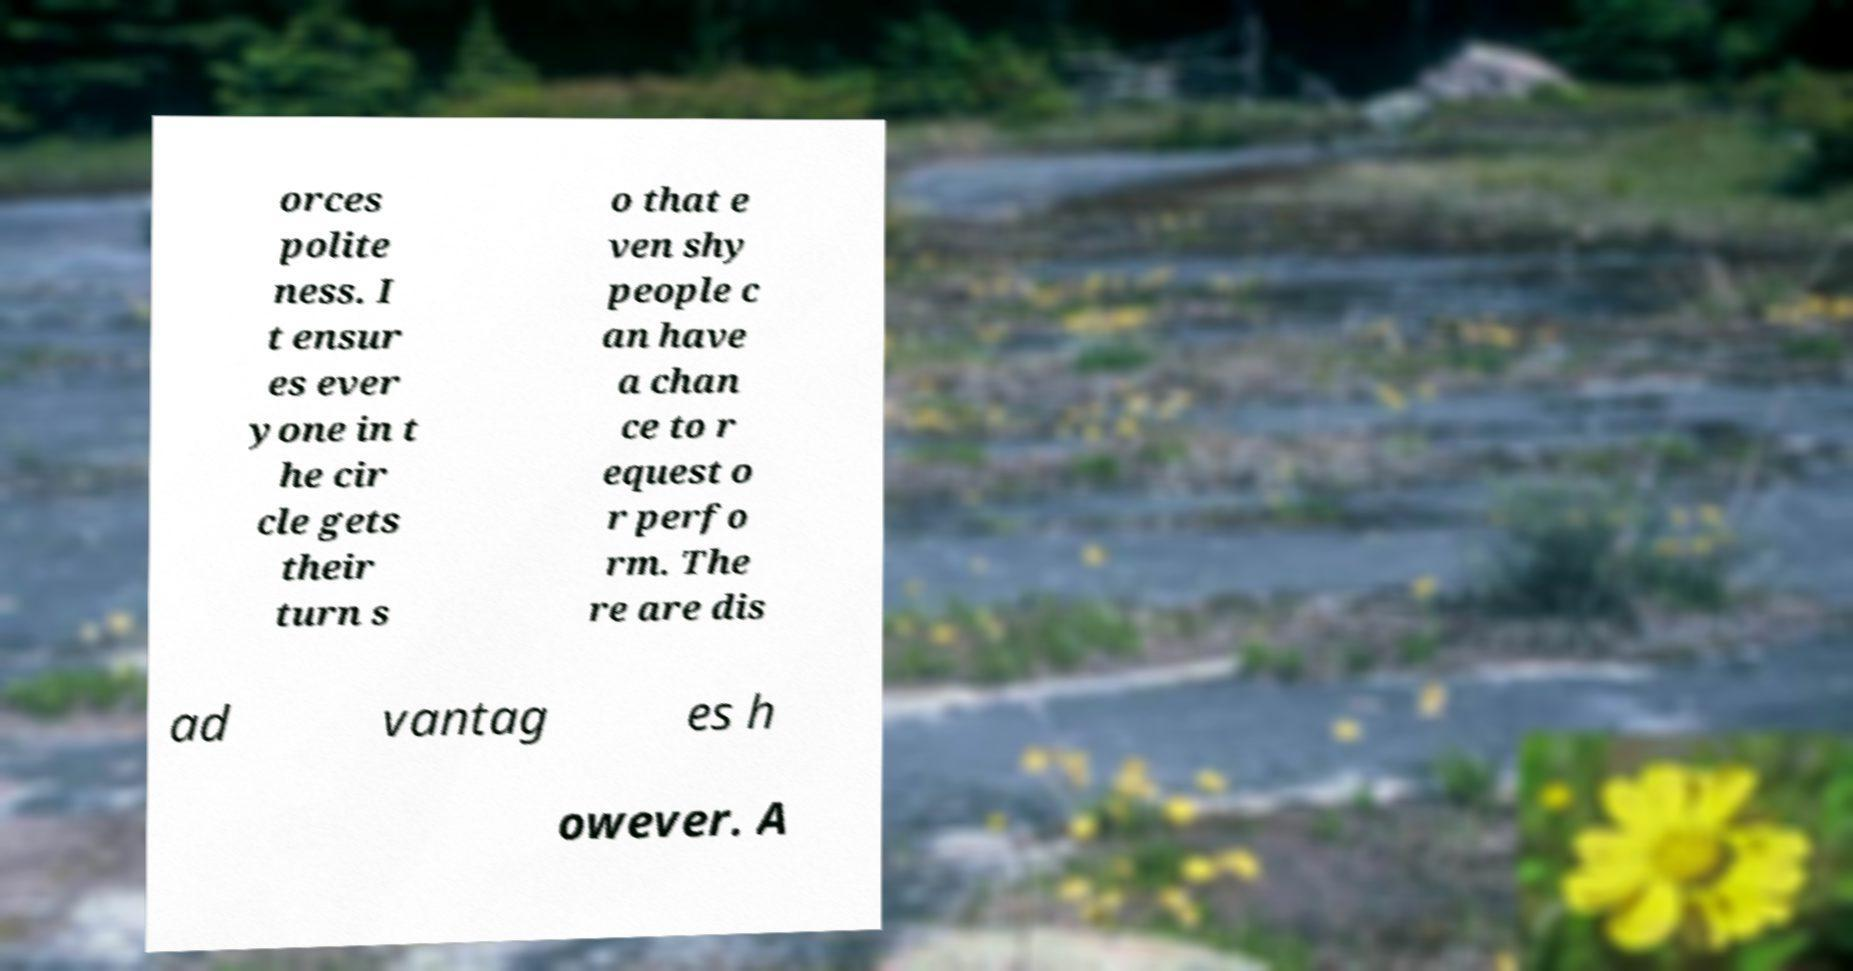What messages or text are displayed in this image? I need them in a readable, typed format. orces polite ness. I t ensur es ever yone in t he cir cle gets their turn s o that e ven shy people c an have a chan ce to r equest o r perfo rm. The re are dis ad vantag es h owever. A 